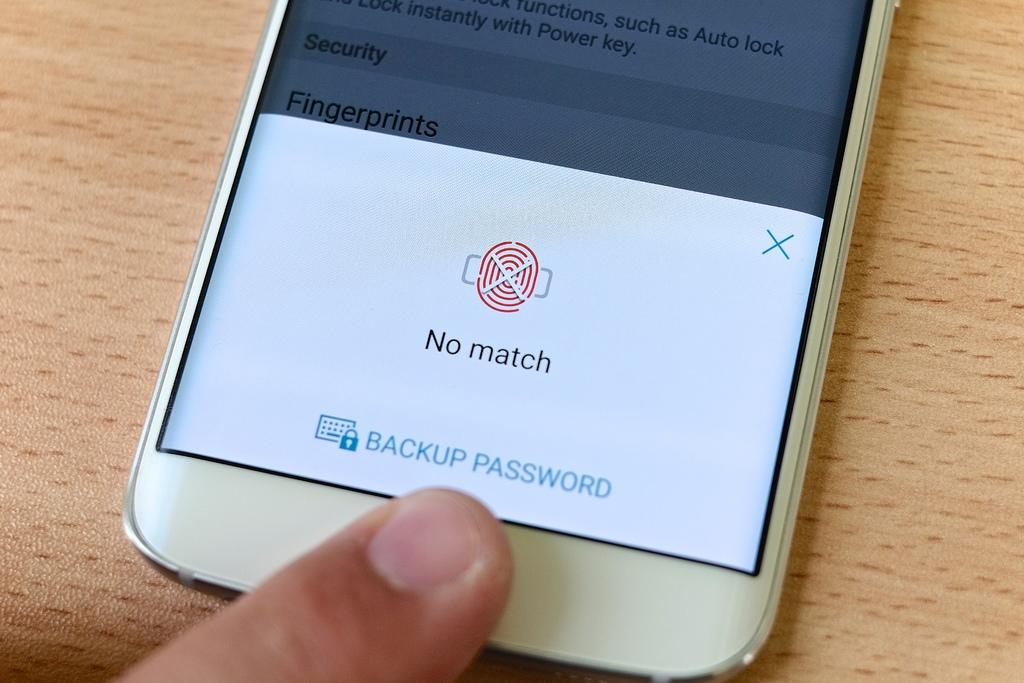Provide a one-sentence caption for the provided image. A cell phone user can't log in because his fingerprint shows no match. 